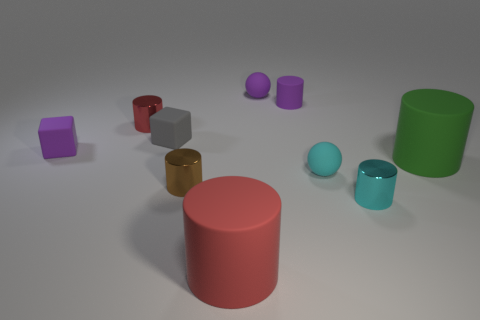Does the tiny rubber cylinder have the same color as the thing that is to the left of the red shiny cylinder?
Provide a short and direct response. Yes. What is the size of the rubber cylinder that is on the right side of the matte sphere in front of the sphere that is on the left side of the cyan matte ball?
Your answer should be very brief. Large. There is a green matte thing; are there any big red objects in front of it?
Ensure brevity in your answer.  Yes. There is a cyan rubber sphere; is its size the same as the red cylinder in front of the purple matte cube?
Your response must be concise. No. How many other things are made of the same material as the tiny brown cylinder?
Offer a very short reply. 2. What shape is the object that is both on the right side of the purple rubber cylinder and to the left of the cyan metal cylinder?
Provide a short and direct response. Sphere. Do the red object to the left of the big red matte object and the red cylinder that is in front of the tiny red metallic thing have the same size?
Your response must be concise. No. There is a red object that is the same material as the small gray thing; what is its shape?
Your answer should be compact. Cylinder. There is a tiny ball that is behind the small matte sphere that is in front of the matte sphere behind the green cylinder; what is its color?
Ensure brevity in your answer.  Purple. Are there fewer small cyan shiny cylinders that are in front of the big red thing than tiny red metal objects behind the tiny brown metal object?
Your answer should be very brief. Yes. 